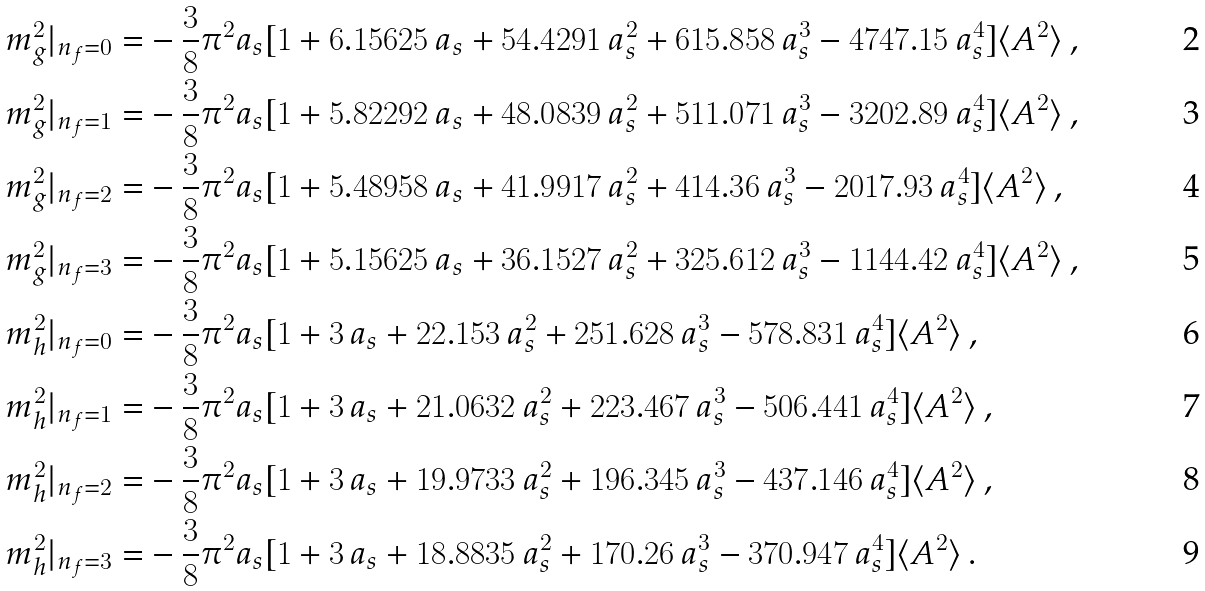<formula> <loc_0><loc_0><loc_500><loc_500>m ^ { 2 } _ { g } | _ { n _ { f } = 0 } = & - \frac { 3 } { 8 } \pi ^ { 2 } a _ { s } [ 1 + 6 . 1 5 6 2 5 \, a _ { s } + 5 4 . 4 2 9 1 \, a _ { s } ^ { 2 } + 6 1 5 . 8 5 8 \, a _ { s } ^ { 3 } - 4 7 4 7 . 1 5 \, a _ { s } ^ { 4 } ] \langle A ^ { 2 } \rangle \, , \\ m ^ { 2 } _ { g } | _ { n _ { f } = 1 } = & - \frac { 3 } { 8 } \pi ^ { 2 } a _ { s } [ 1 + 5 . 8 2 2 9 2 \, a _ { s } + 4 8 . 0 8 3 9 \, a _ { s } ^ { 2 } + 5 1 1 . 0 7 1 \, a _ { s } ^ { 3 } - 3 2 0 2 . 8 9 \, a _ { s } ^ { 4 } ] \langle A ^ { 2 } \rangle \, , \\ m ^ { 2 } _ { g } | _ { n _ { f } = 2 } = & - \frac { 3 } { 8 } \pi ^ { 2 } a _ { s } [ 1 + 5 . 4 8 9 5 8 \, a _ { s } + 4 1 . 9 9 1 7 \, a _ { s } ^ { 2 } + 4 1 4 . 3 6 \, a _ { s } ^ { 3 } - 2 0 1 7 . 9 3 \, a _ { s } ^ { 4 } ] \langle A ^ { 2 } \rangle \, , \\ m ^ { 2 } _ { g } | _ { n _ { f } = 3 } = & - \frac { 3 } { 8 } \pi ^ { 2 } a _ { s } [ 1 + 5 . 1 5 6 2 5 \, a _ { s } + 3 6 . 1 5 2 7 \, a _ { s } ^ { 2 } + 3 2 5 . 6 1 2 \, a _ { s } ^ { 3 } - 1 1 4 4 . 4 2 \, a _ { s } ^ { 4 } ] \langle A ^ { 2 } \rangle \, , \\ m ^ { 2 } _ { h } | _ { n _ { f } = 0 } = & - \frac { 3 } { 8 } \pi ^ { 2 } a _ { s } [ 1 + 3 \, a _ { s } + 2 2 . 1 5 3 \, a _ { s } ^ { 2 } + 2 5 1 . 6 2 8 \, a _ { s } ^ { 3 } - 5 7 8 . 8 3 1 \, a _ { s } ^ { 4 } ] \langle A ^ { 2 } \rangle \, , \\ m ^ { 2 } _ { h } | _ { n _ { f } = 1 } = & - \frac { 3 } { 8 } \pi ^ { 2 } a _ { s } [ 1 + 3 \, a _ { s } + 2 1 . 0 6 3 2 \, a _ { s } ^ { 2 } + 2 2 3 . 4 6 7 \, a _ { s } ^ { 3 } - 5 0 6 . 4 4 1 \, a _ { s } ^ { 4 } ] \langle A ^ { 2 } \rangle \, , \\ m ^ { 2 } _ { h } | _ { n _ { f } = 2 } = & - \frac { 3 } { 8 } \pi ^ { 2 } a _ { s } [ 1 + 3 \, a _ { s } + 1 9 . 9 7 3 3 \, a _ { s } ^ { 2 } + 1 9 6 . 3 4 5 \, a _ { s } ^ { 3 } - 4 3 7 . 1 4 6 \, a _ { s } ^ { 4 } ] \langle A ^ { 2 } \rangle \, , \\ m ^ { 2 } _ { h } | _ { n _ { f } = 3 } = & - \frac { 3 } { 8 } \pi ^ { 2 } a _ { s } [ 1 + 3 \, a _ { s } + 1 8 . 8 8 3 5 \, a _ { s } ^ { 2 } + 1 7 0 . 2 6 \, a _ { s } ^ { 3 } - 3 7 0 . 9 4 7 \, a _ { s } ^ { 4 } ] \langle A ^ { 2 } \rangle \, .</formula> 